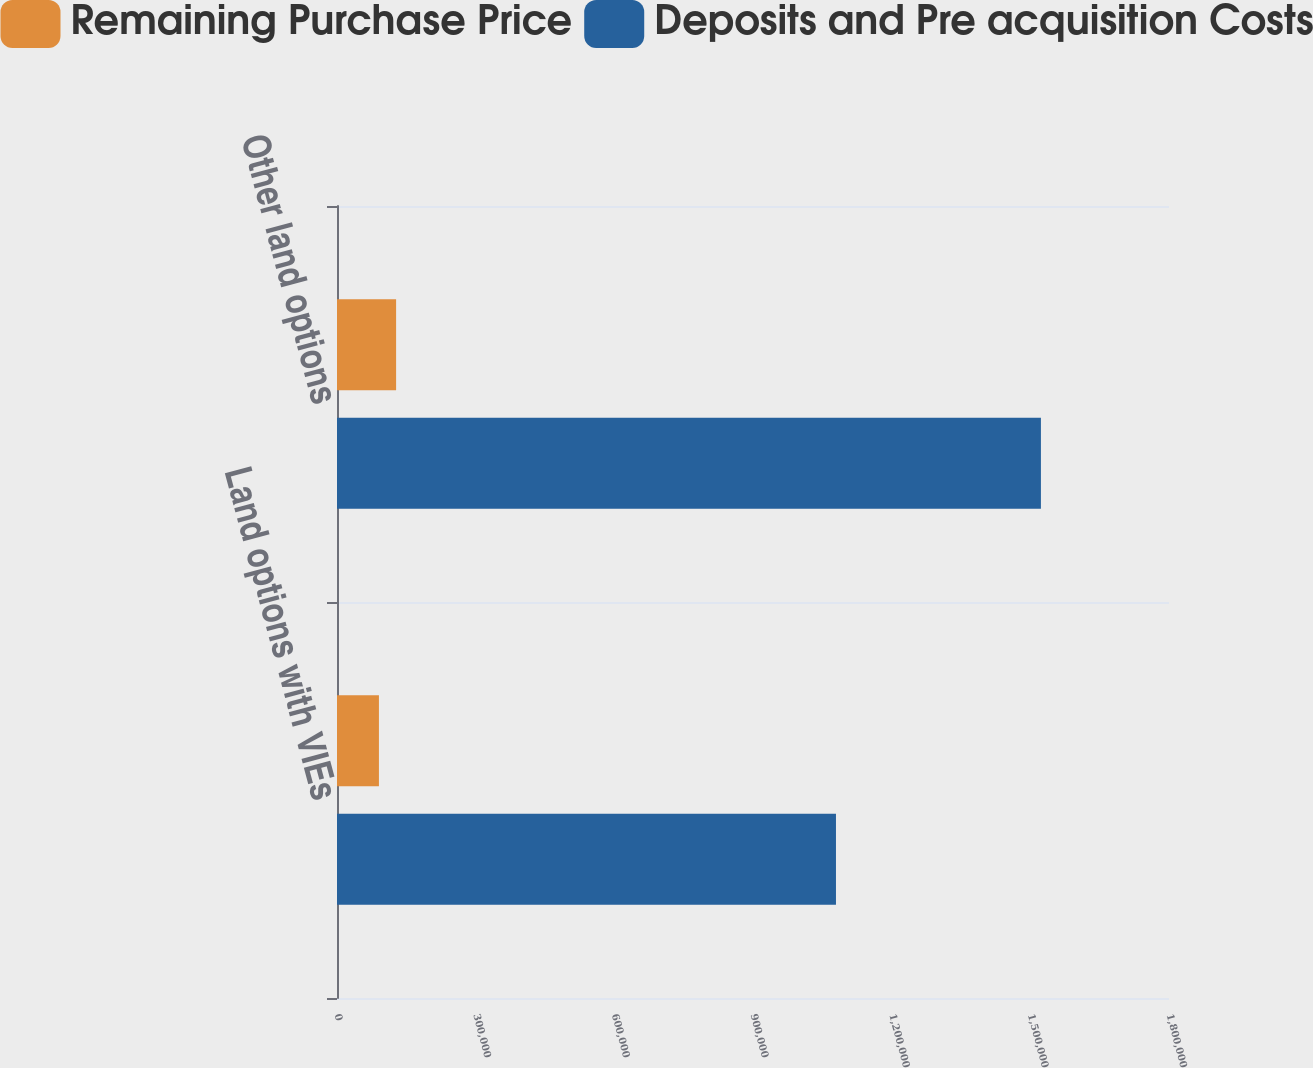Convert chart. <chart><loc_0><loc_0><loc_500><loc_500><stacked_bar_chart><ecel><fcel>Land options with VIEs<fcel>Other land options<nl><fcel>Remaining Purchase Price<fcel>90717<fcel>127851<nl><fcel>Deposits and Pre acquisition Costs<fcel>1.07951e+06<fcel>1.5229e+06<nl></chart> 